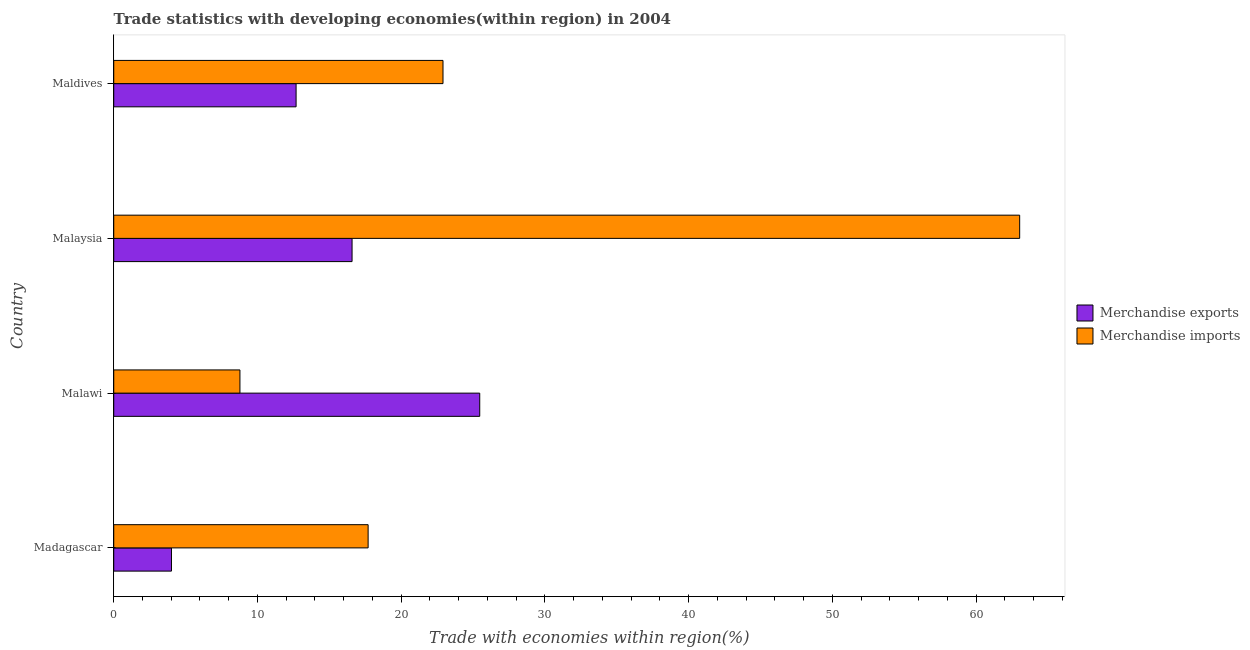Are the number of bars per tick equal to the number of legend labels?
Provide a short and direct response. Yes. What is the label of the 3rd group of bars from the top?
Make the answer very short. Malawi. What is the merchandise exports in Maldives?
Ensure brevity in your answer.  12.69. Across all countries, what is the maximum merchandise exports?
Make the answer very short. 25.47. Across all countries, what is the minimum merchandise imports?
Ensure brevity in your answer.  8.78. In which country was the merchandise imports maximum?
Ensure brevity in your answer.  Malaysia. In which country was the merchandise exports minimum?
Make the answer very short. Madagascar. What is the total merchandise imports in the graph?
Your answer should be compact. 112.43. What is the difference between the merchandise imports in Malawi and that in Maldives?
Your response must be concise. -14.13. What is the difference between the merchandise exports in Malaysia and the merchandise imports in Madagascar?
Give a very brief answer. -1.12. What is the average merchandise imports per country?
Your answer should be compact. 28.11. What is the difference between the merchandise exports and merchandise imports in Malaysia?
Make the answer very short. -46.45. What is the ratio of the merchandise exports in Madagascar to that in Malaysia?
Provide a short and direct response. 0.24. Is the merchandise imports in Madagascar less than that in Maldives?
Provide a succinct answer. Yes. What is the difference between the highest and the second highest merchandise imports?
Your answer should be very brief. 40.12. What is the difference between the highest and the lowest merchandise imports?
Your answer should be very brief. 54.25. In how many countries, is the merchandise imports greater than the average merchandise imports taken over all countries?
Provide a short and direct response. 1. What does the 2nd bar from the bottom in Maldives represents?
Give a very brief answer. Merchandise imports. How many bars are there?
Your answer should be very brief. 8. What is the difference between two consecutive major ticks on the X-axis?
Your answer should be compact. 10. Does the graph contain grids?
Give a very brief answer. No. How many legend labels are there?
Ensure brevity in your answer.  2. What is the title of the graph?
Give a very brief answer. Trade statistics with developing economies(within region) in 2004. What is the label or title of the X-axis?
Offer a terse response. Trade with economies within region(%). What is the label or title of the Y-axis?
Your answer should be compact. Country. What is the Trade with economies within region(%) of Merchandise exports in Madagascar?
Give a very brief answer. 4.02. What is the Trade with economies within region(%) in Merchandise imports in Madagascar?
Provide a succinct answer. 17.7. What is the Trade with economies within region(%) of Merchandise exports in Malawi?
Offer a very short reply. 25.47. What is the Trade with economies within region(%) of Merchandise imports in Malawi?
Offer a terse response. 8.78. What is the Trade with economies within region(%) of Merchandise exports in Malaysia?
Offer a very short reply. 16.58. What is the Trade with economies within region(%) of Merchandise imports in Malaysia?
Make the answer very short. 63.04. What is the Trade with economies within region(%) of Merchandise exports in Maldives?
Your response must be concise. 12.69. What is the Trade with economies within region(%) in Merchandise imports in Maldives?
Your response must be concise. 22.91. Across all countries, what is the maximum Trade with economies within region(%) in Merchandise exports?
Keep it short and to the point. 25.47. Across all countries, what is the maximum Trade with economies within region(%) in Merchandise imports?
Make the answer very short. 63.04. Across all countries, what is the minimum Trade with economies within region(%) of Merchandise exports?
Keep it short and to the point. 4.02. Across all countries, what is the minimum Trade with economies within region(%) in Merchandise imports?
Provide a short and direct response. 8.78. What is the total Trade with economies within region(%) in Merchandise exports in the graph?
Your response must be concise. 58.75. What is the total Trade with economies within region(%) in Merchandise imports in the graph?
Your answer should be compact. 112.43. What is the difference between the Trade with economies within region(%) of Merchandise exports in Madagascar and that in Malawi?
Your answer should be very brief. -21.45. What is the difference between the Trade with economies within region(%) of Merchandise imports in Madagascar and that in Malawi?
Give a very brief answer. 8.92. What is the difference between the Trade with economies within region(%) in Merchandise exports in Madagascar and that in Malaysia?
Give a very brief answer. -12.57. What is the difference between the Trade with economies within region(%) of Merchandise imports in Madagascar and that in Malaysia?
Your answer should be very brief. -45.33. What is the difference between the Trade with economies within region(%) of Merchandise exports in Madagascar and that in Maldives?
Offer a very short reply. -8.67. What is the difference between the Trade with economies within region(%) in Merchandise imports in Madagascar and that in Maldives?
Your response must be concise. -5.21. What is the difference between the Trade with economies within region(%) in Merchandise exports in Malawi and that in Malaysia?
Your response must be concise. 8.88. What is the difference between the Trade with economies within region(%) of Merchandise imports in Malawi and that in Malaysia?
Offer a very short reply. -54.25. What is the difference between the Trade with economies within region(%) in Merchandise exports in Malawi and that in Maldives?
Give a very brief answer. 12.78. What is the difference between the Trade with economies within region(%) in Merchandise imports in Malawi and that in Maldives?
Your response must be concise. -14.13. What is the difference between the Trade with economies within region(%) in Merchandise exports in Malaysia and that in Maldives?
Offer a very short reply. 3.89. What is the difference between the Trade with economies within region(%) of Merchandise imports in Malaysia and that in Maldives?
Your response must be concise. 40.12. What is the difference between the Trade with economies within region(%) of Merchandise exports in Madagascar and the Trade with economies within region(%) of Merchandise imports in Malawi?
Provide a succinct answer. -4.76. What is the difference between the Trade with economies within region(%) in Merchandise exports in Madagascar and the Trade with economies within region(%) in Merchandise imports in Malaysia?
Provide a short and direct response. -59.02. What is the difference between the Trade with economies within region(%) in Merchandise exports in Madagascar and the Trade with economies within region(%) in Merchandise imports in Maldives?
Your answer should be compact. -18.89. What is the difference between the Trade with economies within region(%) in Merchandise exports in Malawi and the Trade with economies within region(%) in Merchandise imports in Malaysia?
Provide a succinct answer. -37.57. What is the difference between the Trade with economies within region(%) of Merchandise exports in Malawi and the Trade with economies within region(%) of Merchandise imports in Maldives?
Keep it short and to the point. 2.56. What is the difference between the Trade with economies within region(%) in Merchandise exports in Malaysia and the Trade with economies within region(%) in Merchandise imports in Maldives?
Provide a short and direct response. -6.33. What is the average Trade with economies within region(%) of Merchandise exports per country?
Your response must be concise. 14.69. What is the average Trade with economies within region(%) in Merchandise imports per country?
Make the answer very short. 28.11. What is the difference between the Trade with economies within region(%) of Merchandise exports and Trade with economies within region(%) of Merchandise imports in Madagascar?
Ensure brevity in your answer.  -13.68. What is the difference between the Trade with economies within region(%) of Merchandise exports and Trade with economies within region(%) of Merchandise imports in Malawi?
Keep it short and to the point. 16.69. What is the difference between the Trade with economies within region(%) of Merchandise exports and Trade with economies within region(%) of Merchandise imports in Malaysia?
Ensure brevity in your answer.  -46.45. What is the difference between the Trade with economies within region(%) of Merchandise exports and Trade with economies within region(%) of Merchandise imports in Maldives?
Your answer should be very brief. -10.22. What is the ratio of the Trade with economies within region(%) in Merchandise exports in Madagascar to that in Malawi?
Provide a succinct answer. 0.16. What is the ratio of the Trade with economies within region(%) of Merchandise imports in Madagascar to that in Malawi?
Offer a very short reply. 2.02. What is the ratio of the Trade with economies within region(%) of Merchandise exports in Madagascar to that in Malaysia?
Your response must be concise. 0.24. What is the ratio of the Trade with economies within region(%) in Merchandise imports in Madagascar to that in Malaysia?
Offer a very short reply. 0.28. What is the ratio of the Trade with economies within region(%) of Merchandise exports in Madagascar to that in Maldives?
Ensure brevity in your answer.  0.32. What is the ratio of the Trade with economies within region(%) of Merchandise imports in Madagascar to that in Maldives?
Offer a very short reply. 0.77. What is the ratio of the Trade with economies within region(%) in Merchandise exports in Malawi to that in Malaysia?
Provide a succinct answer. 1.54. What is the ratio of the Trade with economies within region(%) of Merchandise imports in Malawi to that in Malaysia?
Ensure brevity in your answer.  0.14. What is the ratio of the Trade with economies within region(%) of Merchandise exports in Malawi to that in Maldives?
Keep it short and to the point. 2.01. What is the ratio of the Trade with economies within region(%) in Merchandise imports in Malawi to that in Maldives?
Make the answer very short. 0.38. What is the ratio of the Trade with economies within region(%) of Merchandise exports in Malaysia to that in Maldives?
Offer a terse response. 1.31. What is the ratio of the Trade with economies within region(%) of Merchandise imports in Malaysia to that in Maldives?
Provide a succinct answer. 2.75. What is the difference between the highest and the second highest Trade with economies within region(%) in Merchandise exports?
Ensure brevity in your answer.  8.88. What is the difference between the highest and the second highest Trade with economies within region(%) in Merchandise imports?
Ensure brevity in your answer.  40.12. What is the difference between the highest and the lowest Trade with economies within region(%) in Merchandise exports?
Keep it short and to the point. 21.45. What is the difference between the highest and the lowest Trade with economies within region(%) in Merchandise imports?
Provide a short and direct response. 54.25. 